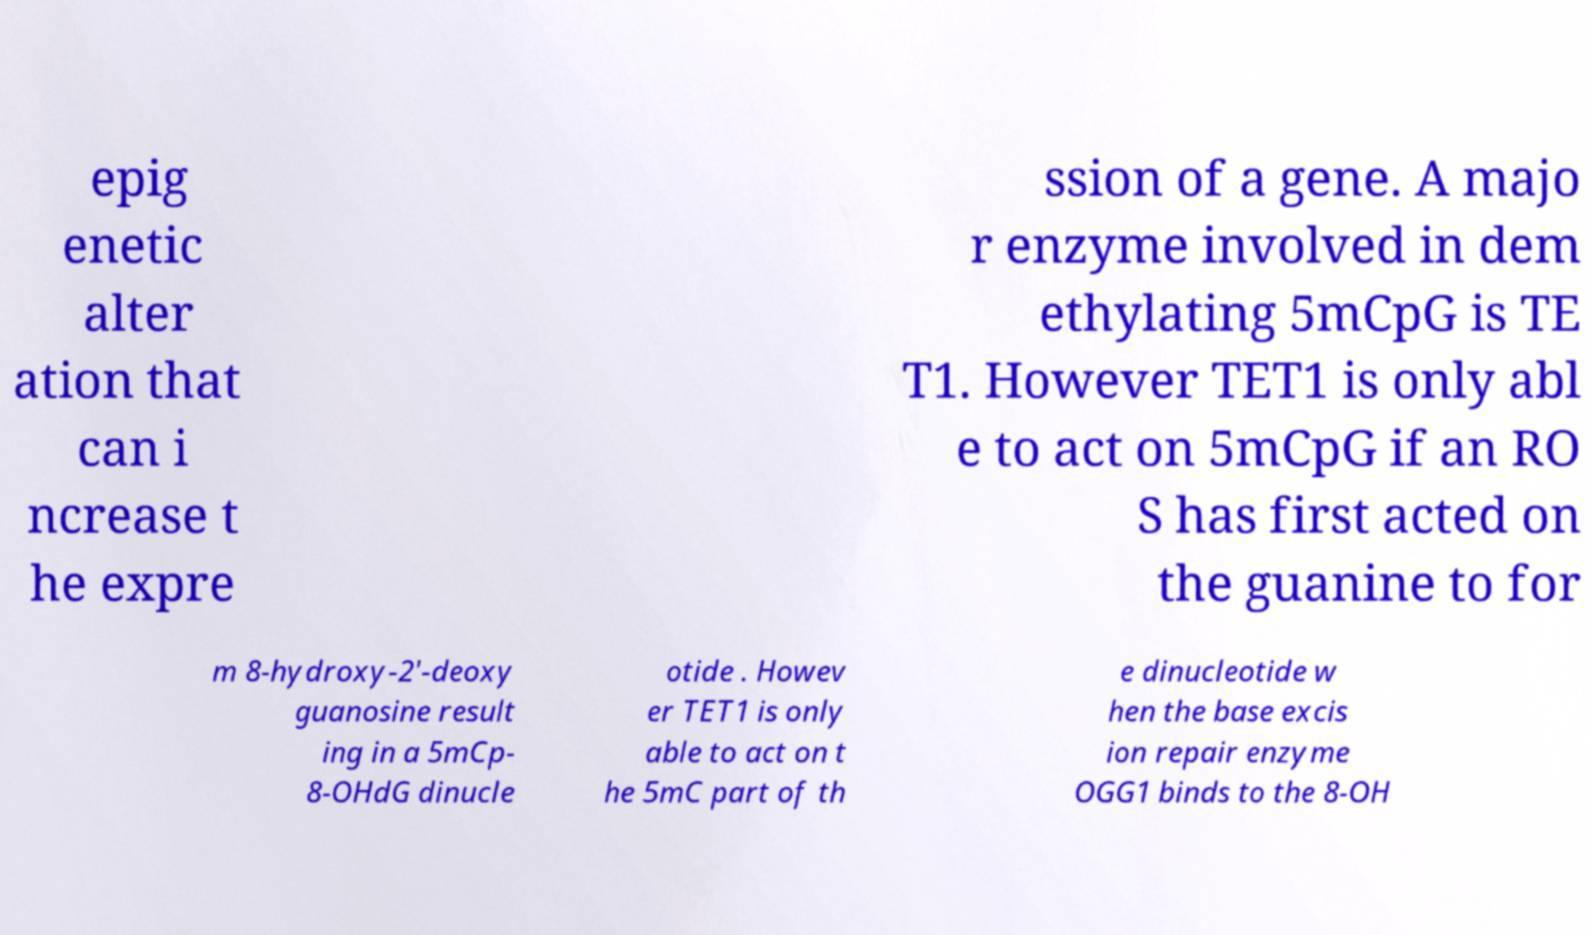Can you read and provide the text displayed in the image?This photo seems to have some interesting text. Can you extract and type it out for me? epig enetic alter ation that can i ncrease t he expre ssion of a gene. A majo r enzyme involved in dem ethylating 5mCpG is TE T1. However TET1 is only abl e to act on 5mCpG if an RO S has first acted on the guanine to for m 8-hydroxy-2'-deoxy guanosine result ing in a 5mCp- 8-OHdG dinucle otide . Howev er TET1 is only able to act on t he 5mC part of th e dinucleotide w hen the base excis ion repair enzyme OGG1 binds to the 8-OH 